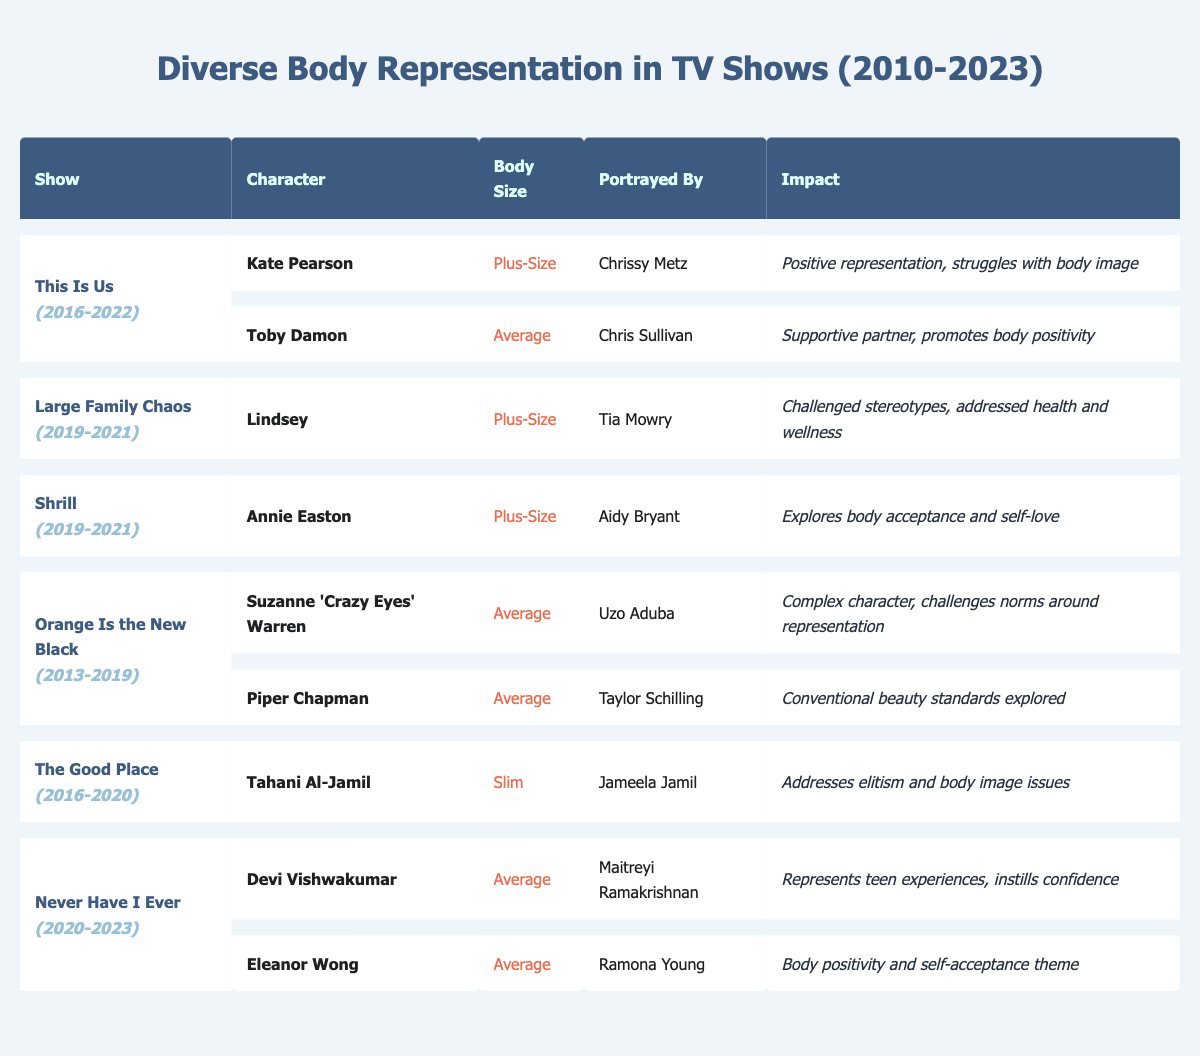What character from "This Is Us" is portrayed by Chrissy Metz? The table shows that Chrissy Metz portrays the character Kate Pearson in the show "This Is Us."
Answer: Kate Pearson How many characters from "Never Have I Ever" are listed in the table? The table lists two characters from "Never Have I Ever": Devi Vishwakumar and Eleanor Wong.
Answer: 2 Which show features a slim character and who portrays her? The show "The Good Place" features the slim character Tahani Al-Jamil, portrayed by Jameela Jamil.
Answer: The Good Place; Jameela Jamil What body size does Toby Damon represent in "This Is Us"? The table specifies that Toby Damon represents the average body size in "This Is Us."
Answer: Average Is there a character in the table who deals positively with body image issues? Yes, multiple characters in the table deal positively with body image issues, such as Kate Pearson and Annie Easton.
Answer: Yes Count the number of shows that feature plus-size characters. The shows with plus-size characters are "This Is Us," "Large Family Chaos," and "Shrill," totaling three shows.
Answer: 3 Do any characters in the table challenge stereotypes about body sizes? Yes, Lindsey from "Large Family Chaos" challenges stereotypes regarding plus-size representations.
Answer: Yes In which years was "Orange Is the New Black" aired? "Orange Is the New Black" was aired from 2013 to 2019, as mentioned in the years column in the table.
Answer: 2013-2019 Which character in the table is associated with a theme of body positivity and self-acceptance? Both Eleanor Wong and Annie Easton are associated with themes of body positivity and self-acceptance in the table.
Answer: Eleanor Wong and Annie Easton How many average body size characters are listed in the table? The table lists a total of four characters classified as average body size: Toby Damon, Suzanne 'Crazy Eyes' Warren, Piper Chapman, and the two from "Never Have I Ever."
Answer: 4 Are there any characters portrayed by the same actor in different shows? No, each character is portrayed by a different actor, with no overlap mentioned in the table.
Answer: No 